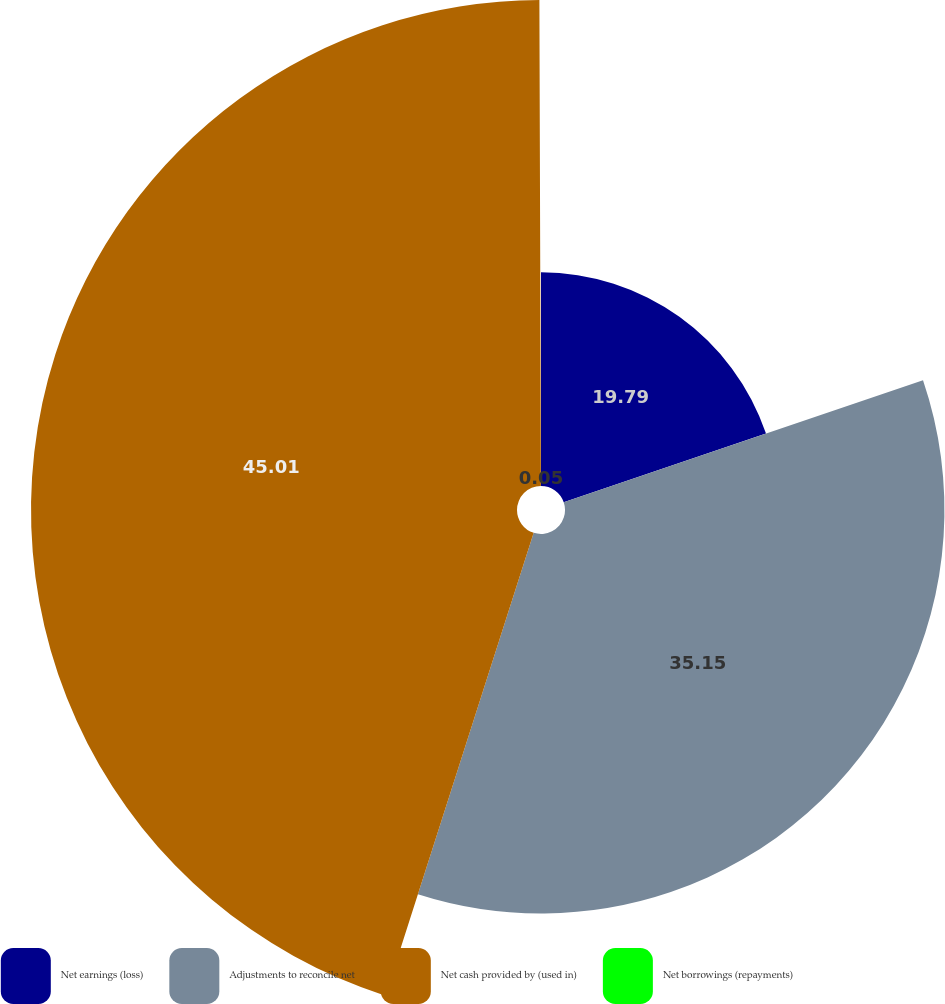Convert chart to OTSL. <chart><loc_0><loc_0><loc_500><loc_500><pie_chart><fcel>Net earnings (loss)<fcel>Adjustments to reconcile net<fcel>Net cash provided by (used in)<fcel>Net borrowings (repayments)<nl><fcel>19.79%<fcel>35.15%<fcel>45.02%<fcel>0.05%<nl></chart> 